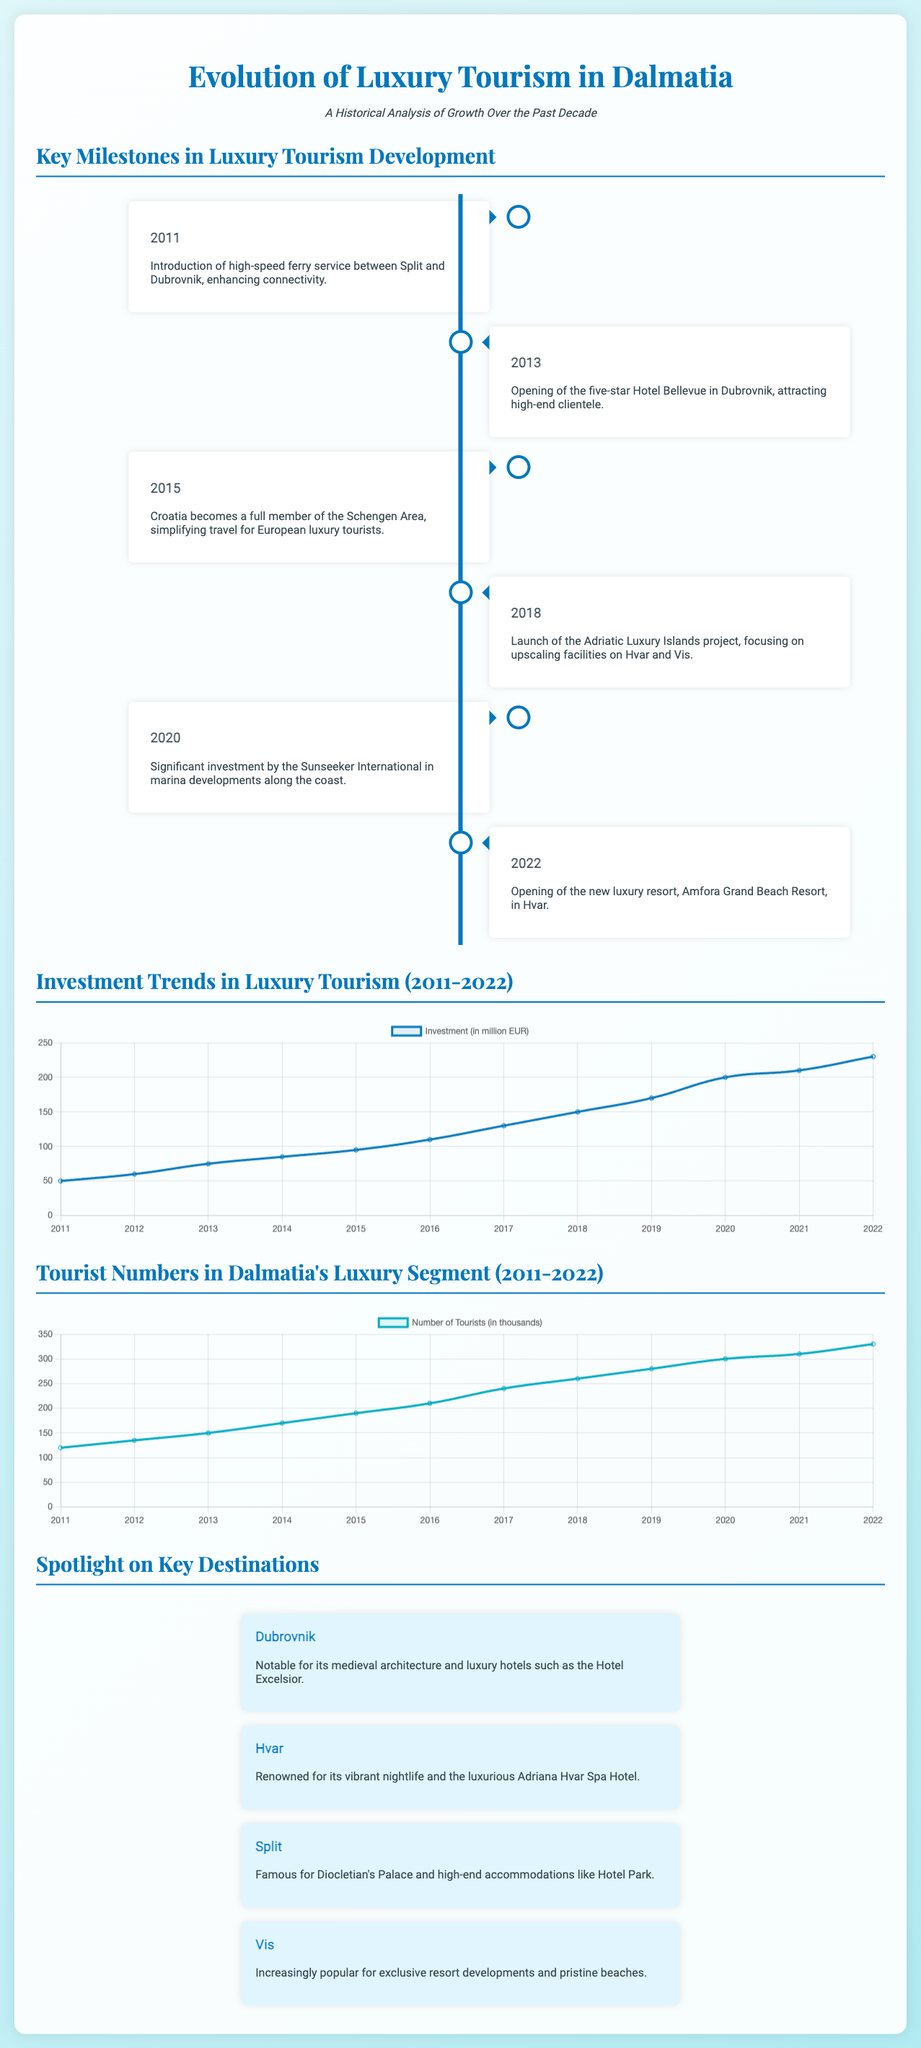What year was the high-speed ferry service introduced? The timeline indicates that the high-speed ferry service was introduced in 2011.
Answer: 2011 What is the investment in luxury tourism for 2022? The investment data for 2022 shows 230 million EUR.
Answer: 230 million EUR Which luxury hotel opened in 2013? According to the timeline, the five-star Hotel Bellevue opened in 2013.
Answer: Hotel Bellevue What was the number of tourists in Dalmatia in 2020? The tourist data shows that the number of tourists in 2020 was 300,000.
Answer: 300,000 In which year did Croatia become a full member of the Schengen Area? The timeline indicates that Croatia became a full member in 2015.
Answer: 2015 What is the main focus of the Adriatic Luxury Islands project launched in 2018? The project focuses on upscaling facilities on Hvar and Vis.
Answer: Upscaling facilities What is the trend in luxury tourism investment from 2011 to 2022? The investment trend shows a steady increase over the years, growing from 50 million EUR to 230 million EUR.
Answer: Steady increase Which destination is noted for the Hotel Excelsior? The spotlight section mentions Dubrovnik as notable for the Hotel Excelsior.
Answer: Dubrovnik What was the number of tourists in Dalmatia in 2012? The tourist data indicates that there were 135,000 tourists in 2012.
Answer: 135,000 